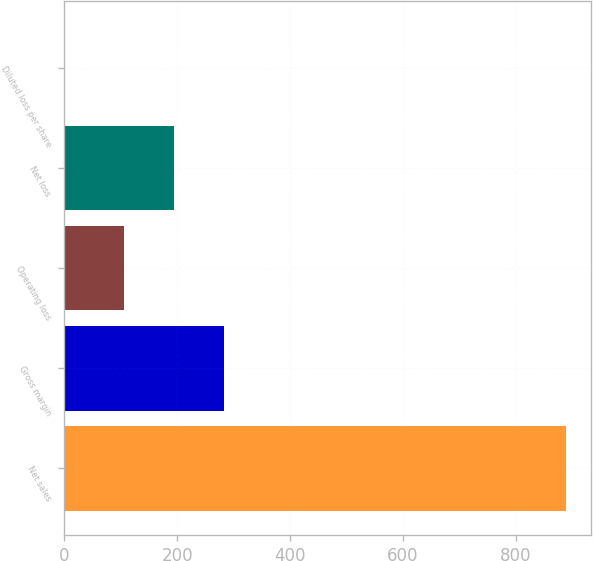Convert chart. <chart><loc_0><loc_0><loc_500><loc_500><bar_chart><fcel>Net sales<fcel>Gross margin<fcel>Operating loss<fcel>Net loss<fcel>Diluted loss per share<nl><fcel>888.5<fcel>283.26<fcel>105.6<fcel>194.43<fcel>0.2<nl></chart> 